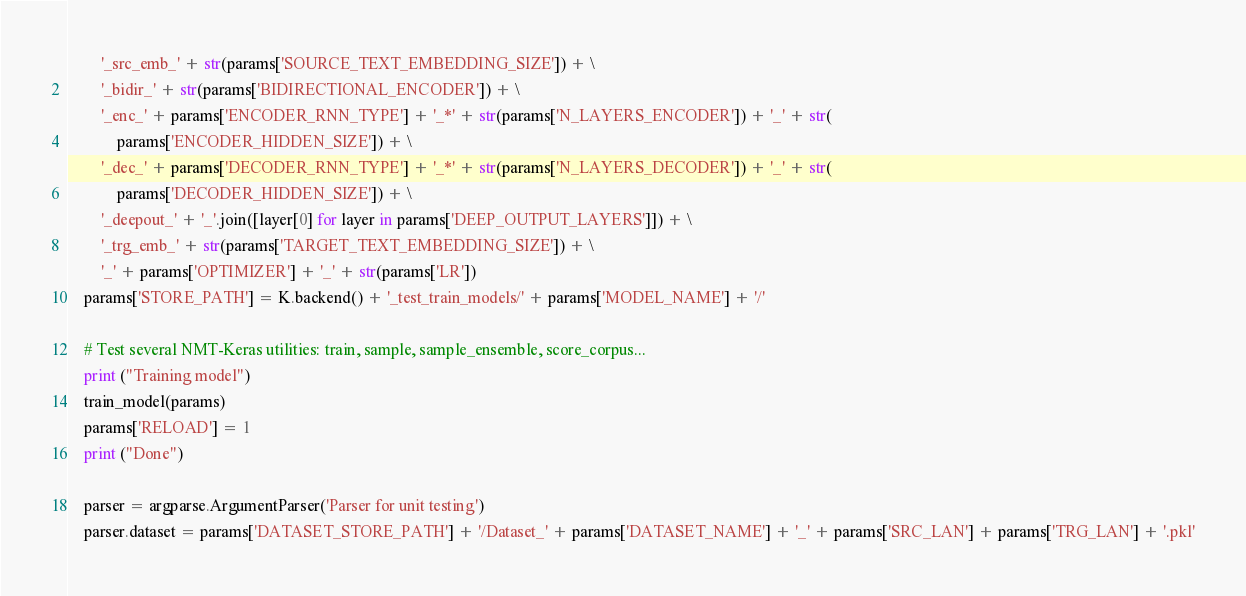Convert code to text. <code><loc_0><loc_0><loc_500><loc_500><_Python_>        '_src_emb_' + str(params['SOURCE_TEXT_EMBEDDING_SIZE']) + \
        '_bidir_' + str(params['BIDIRECTIONAL_ENCODER']) + \
        '_enc_' + params['ENCODER_RNN_TYPE'] + '_*' + str(params['N_LAYERS_ENCODER']) + '_' + str(
            params['ENCODER_HIDDEN_SIZE']) + \
        '_dec_' + params['DECODER_RNN_TYPE'] + '_*' + str(params['N_LAYERS_DECODER']) + '_' + str(
            params['DECODER_HIDDEN_SIZE']) + \
        '_deepout_' + '_'.join([layer[0] for layer in params['DEEP_OUTPUT_LAYERS']]) + \
        '_trg_emb_' + str(params['TARGET_TEXT_EMBEDDING_SIZE']) + \
        '_' + params['OPTIMIZER'] + '_' + str(params['LR'])
    params['STORE_PATH'] = K.backend() + '_test_train_models/' + params['MODEL_NAME'] + '/'

    # Test several NMT-Keras utilities: train, sample, sample_ensemble, score_corpus...
    print ("Training model")
    train_model(params)
    params['RELOAD'] = 1
    print ("Done")

    parser = argparse.ArgumentParser('Parser for unit testing')
    parser.dataset = params['DATASET_STORE_PATH'] + '/Dataset_' + params['DATASET_NAME'] + '_' + params['SRC_LAN'] + params['TRG_LAN'] + '.pkl'
</code> 